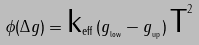<formula> <loc_0><loc_0><loc_500><loc_500>\phi ( \Delta g ) = \text {k} _ { \text {eff} } \, ( g _ { _ { \text {low} } } - g _ { _ { \text {up} } } ) \, \text {T} ^ { 2 }</formula> 